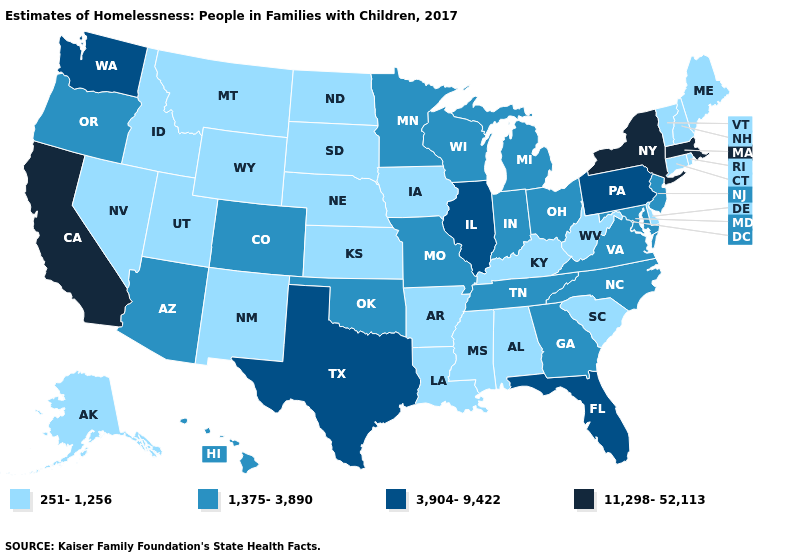What is the value of Oklahoma?
Give a very brief answer. 1,375-3,890. Among the states that border New Jersey , does Delaware have the lowest value?
Short answer required. Yes. Which states have the lowest value in the USA?
Concise answer only. Alabama, Alaska, Arkansas, Connecticut, Delaware, Idaho, Iowa, Kansas, Kentucky, Louisiana, Maine, Mississippi, Montana, Nebraska, Nevada, New Hampshire, New Mexico, North Dakota, Rhode Island, South Carolina, South Dakota, Utah, Vermont, West Virginia, Wyoming. What is the highest value in states that border South Carolina?
Quick response, please. 1,375-3,890. What is the value of Alabama?
Write a very short answer. 251-1,256. What is the value of New Mexico?
Quick response, please. 251-1,256. Does the first symbol in the legend represent the smallest category?
Write a very short answer. Yes. What is the lowest value in the South?
Keep it brief. 251-1,256. What is the value of Washington?
Short answer required. 3,904-9,422. What is the highest value in states that border Iowa?
Concise answer only. 3,904-9,422. How many symbols are there in the legend?
Write a very short answer. 4. Name the states that have a value in the range 251-1,256?
Quick response, please. Alabama, Alaska, Arkansas, Connecticut, Delaware, Idaho, Iowa, Kansas, Kentucky, Louisiana, Maine, Mississippi, Montana, Nebraska, Nevada, New Hampshire, New Mexico, North Dakota, Rhode Island, South Carolina, South Dakota, Utah, Vermont, West Virginia, Wyoming. How many symbols are there in the legend?
Concise answer only. 4. What is the highest value in the USA?
Short answer required. 11,298-52,113. What is the lowest value in states that border Delaware?
Be succinct. 1,375-3,890. 